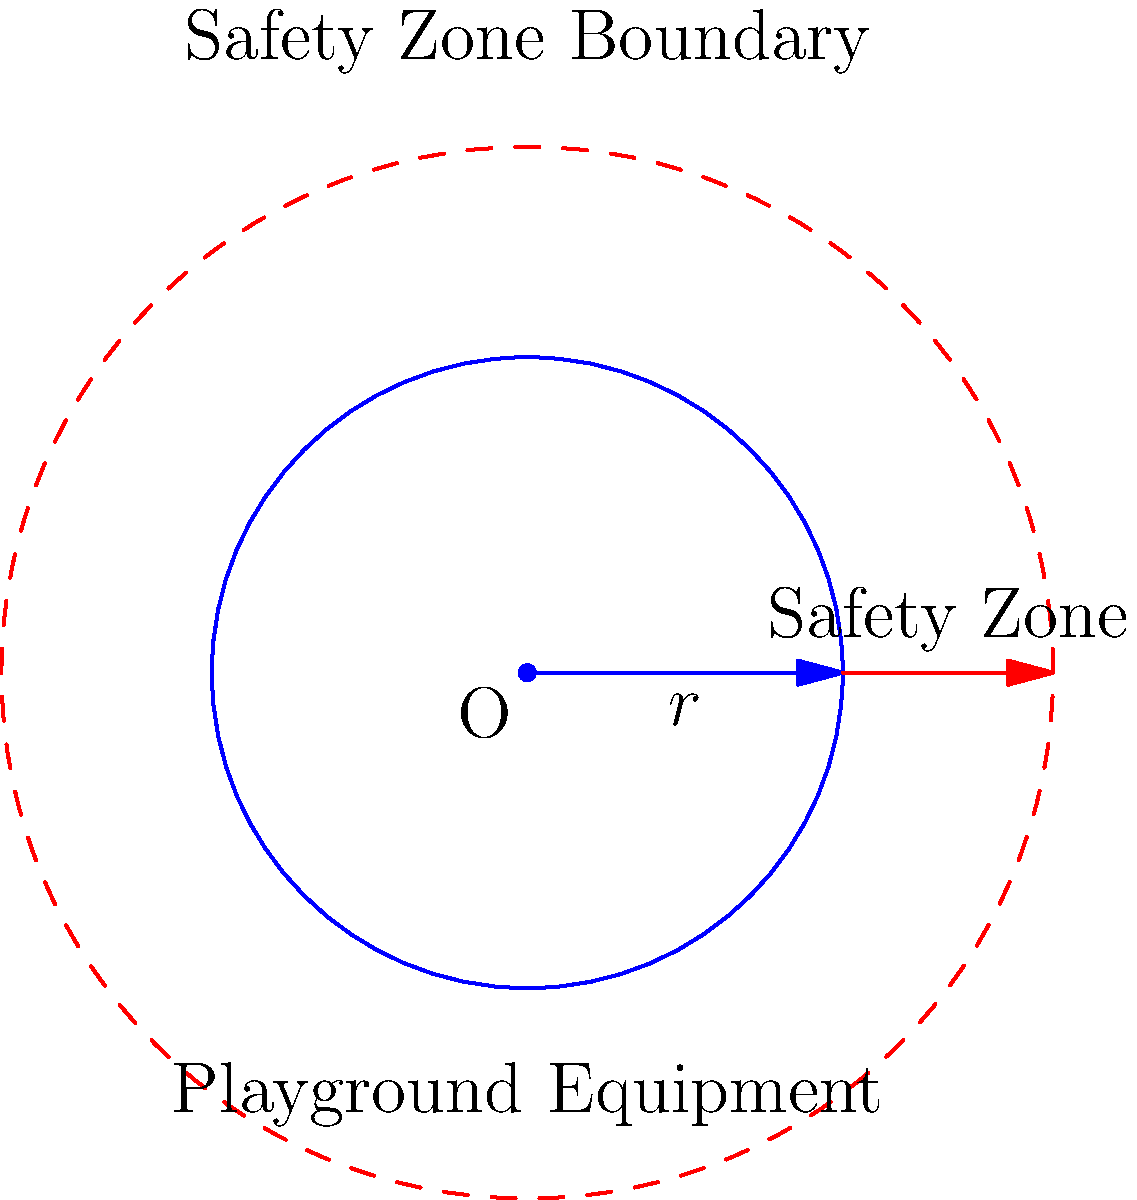A circular playground equipment has a radius of 3 meters. According to safety regulations, a safety zone with a width of 2 meters must surround the equipment. What is the total area that needs to be allocated for this playground equipment, including the safety zone? To find the total area, we need to calculate the area of the larger circle that includes both the playground equipment and the safety zone. Let's approach this step-by-step:

1) The radius of the playground equipment is $r = 3$ meters.
2) The width of the safety zone is $w = 2$ meters.
3) The total radius of the area (equipment + safety zone) is:
   $R = r + w = 3 + 2 = 5$ meters

4) The area of a circle is given by the formula $A = \pi R^2$

5) Substituting our total radius:
   $A = \pi (5)^2 = 25\pi$ square meters

6) If we need to give a numerical value, we can approximate $\pi$ to 3.14159:
   $A \approx 25 * 3.14159 = 78.54$ square meters (rounded to two decimal places)

Therefore, the total area that needs to be allocated is $25\pi$ square meters, or approximately 78.54 square meters.
Answer: $25\pi$ sq m (≈ 78.54 sq m) 